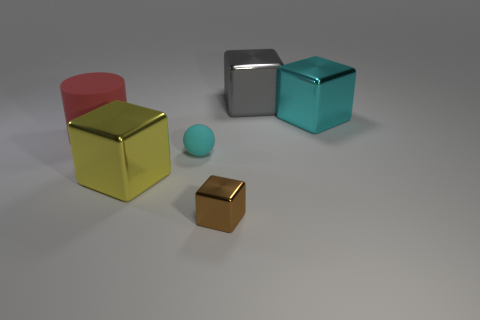Do the small cube and the large metallic cube that is to the left of the tiny cyan matte ball have the same color?
Offer a terse response. No. Is there anything else that is made of the same material as the red cylinder?
Offer a very short reply. Yes. What is the shape of the cyan object that is on the left side of the large object on the right side of the large gray metallic thing?
Keep it short and to the point. Sphere. There is a metal block that is the same color as the tiny ball; what size is it?
Ensure brevity in your answer.  Large. Do the big metal object that is in front of the big cyan block and the big cyan metallic thing have the same shape?
Make the answer very short. Yes. Are there more large metallic objects in front of the small cube than cyan matte objects behind the tiny matte ball?
Provide a succinct answer. No. There is a block left of the small block; what number of tiny brown shiny blocks are behind it?
Make the answer very short. 0. There is a large cube that is the same color as the ball; what is its material?
Give a very brief answer. Metal. How many other things are there of the same color as the large cylinder?
Keep it short and to the point. 0. What is the color of the metal block that is left of the rubber thing that is to the right of the large rubber object?
Offer a very short reply. Yellow. 